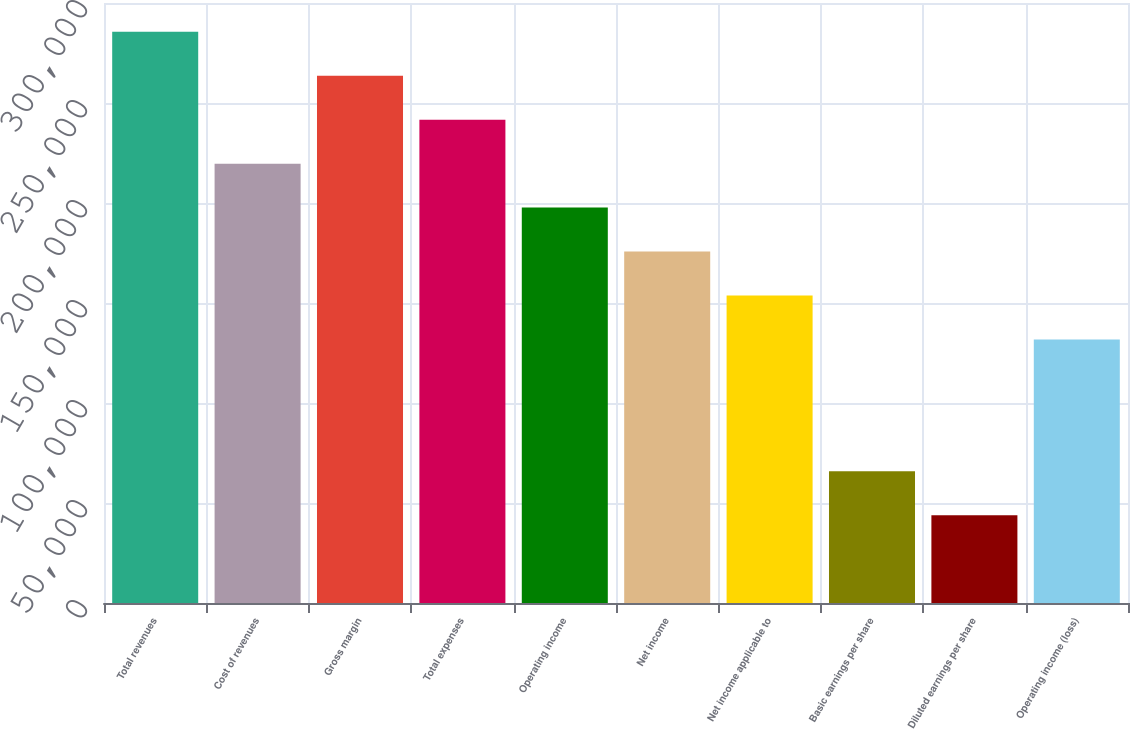Convert chart. <chart><loc_0><loc_0><loc_500><loc_500><bar_chart><fcel>Total revenues<fcel>Cost of revenues<fcel>Gross margin<fcel>Total expenses<fcel>Operating income<fcel>Net income<fcel>Net income applicable to<fcel>Basic earnings per share<fcel>Diluted earnings per share<fcel>Operating income (loss)<nl><fcel>285592<fcel>219686<fcel>263623<fcel>241655<fcel>197717<fcel>175749<fcel>153780<fcel>65905.8<fcel>43937.2<fcel>131812<nl></chart> 